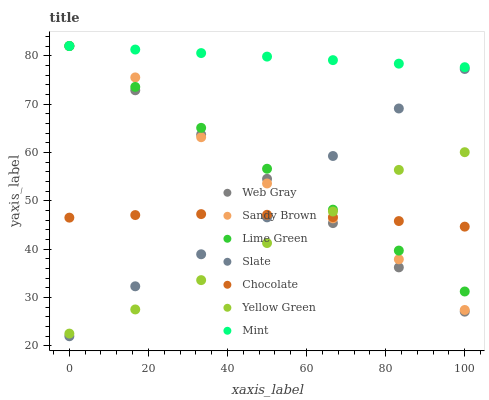Does Yellow Green have the minimum area under the curve?
Answer yes or no. Yes. Does Mint have the maximum area under the curve?
Answer yes or no. Yes. Does Sandy Brown have the minimum area under the curve?
Answer yes or no. No. Does Sandy Brown have the maximum area under the curve?
Answer yes or no. No. Is Lime Green the smoothest?
Answer yes or no. Yes. Is Sandy Brown the roughest?
Answer yes or no. Yes. Is Yellow Green the smoothest?
Answer yes or no. No. Is Yellow Green the roughest?
Answer yes or no. No. Does Slate have the lowest value?
Answer yes or no. Yes. Does Yellow Green have the lowest value?
Answer yes or no. No. Does Mint have the highest value?
Answer yes or no. Yes. Does Yellow Green have the highest value?
Answer yes or no. No. Is Slate less than Mint?
Answer yes or no. Yes. Is Mint greater than Chocolate?
Answer yes or no. Yes. Does Slate intersect Chocolate?
Answer yes or no. Yes. Is Slate less than Chocolate?
Answer yes or no. No. Is Slate greater than Chocolate?
Answer yes or no. No. Does Slate intersect Mint?
Answer yes or no. No. 